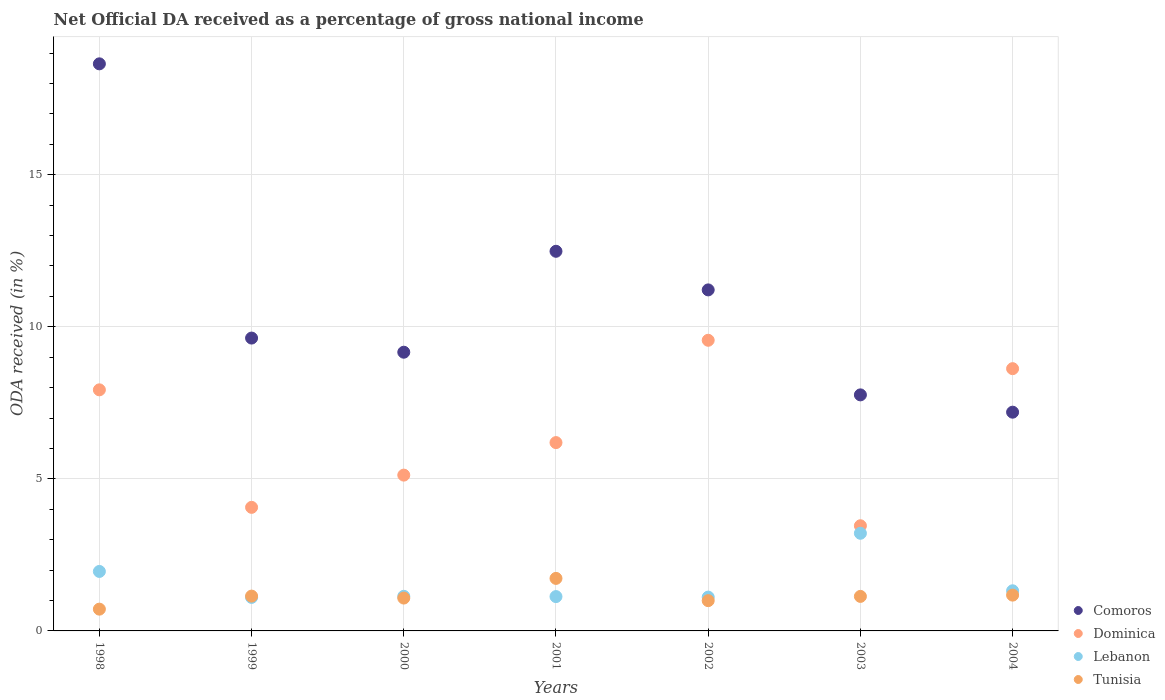Is the number of dotlines equal to the number of legend labels?
Offer a terse response. Yes. What is the net official DA received in Comoros in 2000?
Offer a terse response. 9.16. Across all years, what is the maximum net official DA received in Dominica?
Provide a succinct answer. 9.56. Across all years, what is the minimum net official DA received in Lebanon?
Ensure brevity in your answer.  1.1. In which year was the net official DA received in Dominica minimum?
Provide a short and direct response. 2003. What is the total net official DA received in Tunisia in the graph?
Keep it short and to the point. 7.98. What is the difference between the net official DA received in Comoros in 1999 and that in 2001?
Keep it short and to the point. -2.85. What is the difference between the net official DA received in Comoros in 2002 and the net official DA received in Dominica in 2000?
Offer a terse response. 6.09. What is the average net official DA received in Lebanon per year?
Make the answer very short. 1.57. In the year 1998, what is the difference between the net official DA received in Tunisia and net official DA received in Comoros?
Your response must be concise. -17.93. What is the ratio of the net official DA received in Dominica in 1998 to that in 2004?
Your answer should be very brief. 0.92. Is the net official DA received in Lebanon in 1998 less than that in 1999?
Make the answer very short. No. Is the difference between the net official DA received in Tunisia in 2000 and 2001 greater than the difference between the net official DA received in Comoros in 2000 and 2001?
Your response must be concise. Yes. What is the difference between the highest and the second highest net official DA received in Tunisia?
Your answer should be very brief. 0.55. What is the difference between the highest and the lowest net official DA received in Dominica?
Give a very brief answer. 6.1. Is the sum of the net official DA received in Lebanon in 1998 and 2004 greater than the maximum net official DA received in Dominica across all years?
Your answer should be compact. No. Is it the case that in every year, the sum of the net official DA received in Comoros and net official DA received in Tunisia  is greater than the sum of net official DA received in Lebanon and net official DA received in Dominica?
Provide a succinct answer. No. Is it the case that in every year, the sum of the net official DA received in Tunisia and net official DA received in Comoros  is greater than the net official DA received in Lebanon?
Keep it short and to the point. Yes. Is the net official DA received in Dominica strictly greater than the net official DA received in Lebanon over the years?
Make the answer very short. Yes. How many years are there in the graph?
Give a very brief answer. 7. What is the difference between two consecutive major ticks on the Y-axis?
Offer a very short reply. 5. Where does the legend appear in the graph?
Keep it short and to the point. Bottom right. How many legend labels are there?
Give a very brief answer. 4. How are the legend labels stacked?
Provide a succinct answer. Vertical. What is the title of the graph?
Your response must be concise. Net Official DA received as a percentage of gross national income. What is the label or title of the X-axis?
Make the answer very short. Years. What is the label or title of the Y-axis?
Your answer should be compact. ODA received (in %). What is the ODA received (in %) in Comoros in 1998?
Offer a terse response. 18.64. What is the ODA received (in %) of Dominica in 1998?
Provide a succinct answer. 7.93. What is the ODA received (in %) of Lebanon in 1998?
Your answer should be very brief. 1.96. What is the ODA received (in %) of Tunisia in 1998?
Make the answer very short. 0.72. What is the ODA received (in %) of Comoros in 1999?
Make the answer very short. 9.63. What is the ODA received (in %) of Dominica in 1999?
Offer a very short reply. 4.06. What is the ODA received (in %) in Lebanon in 1999?
Ensure brevity in your answer.  1.1. What is the ODA received (in %) in Tunisia in 1999?
Your response must be concise. 1.14. What is the ODA received (in %) in Comoros in 2000?
Offer a terse response. 9.16. What is the ODA received (in %) of Dominica in 2000?
Give a very brief answer. 5.12. What is the ODA received (in %) in Lebanon in 2000?
Provide a succinct answer. 1.14. What is the ODA received (in %) in Tunisia in 2000?
Your answer should be compact. 1.08. What is the ODA received (in %) of Comoros in 2001?
Give a very brief answer. 12.48. What is the ODA received (in %) in Dominica in 2001?
Your answer should be compact. 6.19. What is the ODA received (in %) in Lebanon in 2001?
Keep it short and to the point. 1.13. What is the ODA received (in %) of Tunisia in 2001?
Your answer should be compact. 1.73. What is the ODA received (in %) in Comoros in 2002?
Give a very brief answer. 11.21. What is the ODA received (in %) in Dominica in 2002?
Your answer should be compact. 9.56. What is the ODA received (in %) of Lebanon in 2002?
Make the answer very short. 1.11. What is the ODA received (in %) of Tunisia in 2002?
Your answer should be very brief. 1. What is the ODA received (in %) of Comoros in 2003?
Your answer should be very brief. 7.76. What is the ODA received (in %) in Dominica in 2003?
Ensure brevity in your answer.  3.46. What is the ODA received (in %) of Lebanon in 2003?
Offer a very short reply. 3.21. What is the ODA received (in %) in Tunisia in 2003?
Your answer should be compact. 1.14. What is the ODA received (in %) of Comoros in 2004?
Your answer should be compact. 7.19. What is the ODA received (in %) of Dominica in 2004?
Your response must be concise. 8.62. What is the ODA received (in %) in Lebanon in 2004?
Your answer should be very brief. 1.32. What is the ODA received (in %) in Tunisia in 2004?
Your response must be concise. 1.18. Across all years, what is the maximum ODA received (in %) in Comoros?
Offer a terse response. 18.64. Across all years, what is the maximum ODA received (in %) in Dominica?
Offer a very short reply. 9.56. Across all years, what is the maximum ODA received (in %) of Lebanon?
Offer a terse response. 3.21. Across all years, what is the maximum ODA received (in %) of Tunisia?
Offer a very short reply. 1.73. Across all years, what is the minimum ODA received (in %) in Comoros?
Your response must be concise. 7.19. Across all years, what is the minimum ODA received (in %) in Dominica?
Make the answer very short. 3.46. Across all years, what is the minimum ODA received (in %) in Lebanon?
Give a very brief answer. 1.1. Across all years, what is the minimum ODA received (in %) in Tunisia?
Offer a terse response. 0.72. What is the total ODA received (in %) in Comoros in the graph?
Your response must be concise. 76.08. What is the total ODA received (in %) of Dominica in the graph?
Provide a short and direct response. 44.94. What is the total ODA received (in %) of Lebanon in the graph?
Ensure brevity in your answer.  10.97. What is the total ODA received (in %) of Tunisia in the graph?
Make the answer very short. 7.98. What is the difference between the ODA received (in %) in Comoros in 1998 and that in 1999?
Ensure brevity in your answer.  9.02. What is the difference between the ODA received (in %) of Dominica in 1998 and that in 1999?
Keep it short and to the point. 3.86. What is the difference between the ODA received (in %) in Lebanon in 1998 and that in 1999?
Ensure brevity in your answer.  0.85. What is the difference between the ODA received (in %) in Tunisia in 1998 and that in 1999?
Provide a short and direct response. -0.43. What is the difference between the ODA received (in %) of Comoros in 1998 and that in 2000?
Keep it short and to the point. 9.48. What is the difference between the ODA received (in %) of Dominica in 1998 and that in 2000?
Your response must be concise. 2.8. What is the difference between the ODA received (in %) of Lebanon in 1998 and that in 2000?
Your answer should be compact. 0.82. What is the difference between the ODA received (in %) in Tunisia in 1998 and that in 2000?
Your answer should be very brief. -0.36. What is the difference between the ODA received (in %) in Comoros in 1998 and that in 2001?
Your answer should be compact. 6.16. What is the difference between the ODA received (in %) of Dominica in 1998 and that in 2001?
Your answer should be very brief. 1.73. What is the difference between the ODA received (in %) of Lebanon in 1998 and that in 2001?
Your response must be concise. 0.83. What is the difference between the ODA received (in %) in Tunisia in 1998 and that in 2001?
Provide a succinct answer. -1.01. What is the difference between the ODA received (in %) of Comoros in 1998 and that in 2002?
Your response must be concise. 7.43. What is the difference between the ODA received (in %) in Dominica in 1998 and that in 2002?
Make the answer very short. -1.63. What is the difference between the ODA received (in %) of Lebanon in 1998 and that in 2002?
Give a very brief answer. 0.84. What is the difference between the ODA received (in %) in Tunisia in 1998 and that in 2002?
Make the answer very short. -0.28. What is the difference between the ODA received (in %) in Comoros in 1998 and that in 2003?
Provide a short and direct response. 10.88. What is the difference between the ODA received (in %) in Dominica in 1998 and that in 2003?
Provide a short and direct response. 4.47. What is the difference between the ODA received (in %) in Lebanon in 1998 and that in 2003?
Ensure brevity in your answer.  -1.25. What is the difference between the ODA received (in %) in Tunisia in 1998 and that in 2003?
Offer a very short reply. -0.42. What is the difference between the ODA received (in %) of Comoros in 1998 and that in 2004?
Keep it short and to the point. 11.45. What is the difference between the ODA received (in %) in Dominica in 1998 and that in 2004?
Provide a short and direct response. -0.7. What is the difference between the ODA received (in %) in Lebanon in 1998 and that in 2004?
Give a very brief answer. 0.64. What is the difference between the ODA received (in %) in Tunisia in 1998 and that in 2004?
Give a very brief answer. -0.46. What is the difference between the ODA received (in %) in Comoros in 1999 and that in 2000?
Give a very brief answer. 0.47. What is the difference between the ODA received (in %) of Dominica in 1999 and that in 2000?
Give a very brief answer. -1.06. What is the difference between the ODA received (in %) of Lebanon in 1999 and that in 2000?
Keep it short and to the point. -0.04. What is the difference between the ODA received (in %) of Tunisia in 1999 and that in 2000?
Provide a short and direct response. 0.06. What is the difference between the ODA received (in %) in Comoros in 1999 and that in 2001?
Ensure brevity in your answer.  -2.85. What is the difference between the ODA received (in %) of Dominica in 1999 and that in 2001?
Keep it short and to the point. -2.13. What is the difference between the ODA received (in %) in Lebanon in 1999 and that in 2001?
Keep it short and to the point. -0.03. What is the difference between the ODA received (in %) of Tunisia in 1999 and that in 2001?
Provide a short and direct response. -0.58. What is the difference between the ODA received (in %) of Comoros in 1999 and that in 2002?
Your response must be concise. -1.58. What is the difference between the ODA received (in %) of Dominica in 1999 and that in 2002?
Keep it short and to the point. -5.49. What is the difference between the ODA received (in %) in Lebanon in 1999 and that in 2002?
Give a very brief answer. -0.01. What is the difference between the ODA received (in %) of Tunisia in 1999 and that in 2002?
Provide a succinct answer. 0.15. What is the difference between the ODA received (in %) of Comoros in 1999 and that in 2003?
Make the answer very short. 1.87. What is the difference between the ODA received (in %) of Dominica in 1999 and that in 2003?
Offer a terse response. 0.61. What is the difference between the ODA received (in %) in Lebanon in 1999 and that in 2003?
Offer a terse response. -2.11. What is the difference between the ODA received (in %) in Tunisia in 1999 and that in 2003?
Offer a terse response. 0.01. What is the difference between the ODA received (in %) in Comoros in 1999 and that in 2004?
Provide a short and direct response. 2.44. What is the difference between the ODA received (in %) in Dominica in 1999 and that in 2004?
Make the answer very short. -4.56. What is the difference between the ODA received (in %) of Lebanon in 1999 and that in 2004?
Offer a very short reply. -0.22. What is the difference between the ODA received (in %) of Tunisia in 1999 and that in 2004?
Give a very brief answer. -0.03. What is the difference between the ODA received (in %) of Comoros in 2000 and that in 2001?
Give a very brief answer. -3.32. What is the difference between the ODA received (in %) in Dominica in 2000 and that in 2001?
Give a very brief answer. -1.07. What is the difference between the ODA received (in %) in Lebanon in 2000 and that in 2001?
Provide a short and direct response. 0.01. What is the difference between the ODA received (in %) in Tunisia in 2000 and that in 2001?
Give a very brief answer. -0.65. What is the difference between the ODA received (in %) in Comoros in 2000 and that in 2002?
Provide a succinct answer. -2.05. What is the difference between the ODA received (in %) in Dominica in 2000 and that in 2002?
Keep it short and to the point. -4.43. What is the difference between the ODA received (in %) in Lebanon in 2000 and that in 2002?
Give a very brief answer. 0.03. What is the difference between the ODA received (in %) of Tunisia in 2000 and that in 2002?
Ensure brevity in your answer.  0.09. What is the difference between the ODA received (in %) in Comoros in 2000 and that in 2003?
Keep it short and to the point. 1.4. What is the difference between the ODA received (in %) of Dominica in 2000 and that in 2003?
Make the answer very short. 1.67. What is the difference between the ODA received (in %) in Lebanon in 2000 and that in 2003?
Ensure brevity in your answer.  -2.07. What is the difference between the ODA received (in %) of Tunisia in 2000 and that in 2003?
Offer a very short reply. -0.05. What is the difference between the ODA received (in %) in Comoros in 2000 and that in 2004?
Your answer should be compact. 1.97. What is the difference between the ODA received (in %) in Dominica in 2000 and that in 2004?
Provide a succinct answer. -3.5. What is the difference between the ODA received (in %) in Lebanon in 2000 and that in 2004?
Your response must be concise. -0.18. What is the difference between the ODA received (in %) in Tunisia in 2000 and that in 2004?
Provide a short and direct response. -0.1. What is the difference between the ODA received (in %) in Comoros in 2001 and that in 2002?
Keep it short and to the point. 1.27. What is the difference between the ODA received (in %) of Dominica in 2001 and that in 2002?
Offer a terse response. -3.36. What is the difference between the ODA received (in %) in Lebanon in 2001 and that in 2002?
Offer a very short reply. 0.02. What is the difference between the ODA received (in %) of Tunisia in 2001 and that in 2002?
Make the answer very short. 0.73. What is the difference between the ODA received (in %) in Comoros in 2001 and that in 2003?
Offer a terse response. 4.72. What is the difference between the ODA received (in %) of Dominica in 2001 and that in 2003?
Provide a succinct answer. 2.73. What is the difference between the ODA received (in %) in Lebanon in 2001 and that in 2003?
Keep it short and to the point. -2.08. What is the difference between the ODA received (in %) of Tunisia in 2001 and that in 2003?
Your answer should be very brief. 0.59. What is the difference between the ODA received (in %) in Comoros in 2001 and that in 2004?
Offer a terse response. 5.29. What is the difference between the ODA received (in %) in Dominica in 2001 and that in 2004?
Give a very brief answer. -2.43. What is the difference between the ODA received (in %) of Lebanon in 2001 and that in 2004?
Provide a succinct answer. -0.19. What is the difference between the ODA received (in %) in Tunisia in 2001 and that in 2004?
Make the answer very short. 0.55. What is the difference between the ODA received (in %) in Comoros in 2002 and that in 2003?
Your answer should be compact. 3.45. What is the difference between the ODA received (in %) in Dominica in 2002 and that in 2003?
Give a very brief answer. 6.1. What is the difference between the ODA received (in %) of Lebanon in 2002 and that in 2003?
Offer a terse response. -2.1. What is the difference between the ODA received (in %) of Tunisia in 2002 and that in 2003?
Your response must be concise. -0.14. What is the difference between the ODA received (in %) in Comoros in 2002 and that in 2004?
Make the answer very short. 4.02. What is the difference between the ODA received (in %) of Dominica in 2002 and that in 2004?
Provide a short and direct response. 0.93. What is the difference between the ODA received (in %) of Lebanon in 2002 and that in 2004?
Make the answer very short. -0.21. What is the difference between the ODA received (in %) in Tunisia in 2002 and that in 2004?
Give a very brief answer. -0.18. What is the difference between the ODA received (in %) in Comoros in 2003 and that in 2004?
Ensure brevity in your answer.  0.57. What is the difference between the ODA received (in %) in Dominica in 2003 and that in 2004?
Your answer should be very brief. -5.16. What is the difference between the ODA received (in %) in Lebanon in 2003 and that in 2004?
Offer a terse response. 1.89. What is the difference between the ODA received (in %) in Tunisia in 2003 and that in 2004?
Keep it short and to the point. -0.04. What is the difference between the ODA received (in %) in Comoros in 1998 and the ODA received (in %) in Dominica in 1999?
Keep it short and to the point. 14.58. What is the difference between the ODA received (in %) in Comoros in 1998 and the ODA received (in %) in Lebanon in 1999?
Offer a terse response. 17.54. What is the difference between the ODA received (in %) in Comoros in 1998 and the ODA received (in %) in Tunisia in 1999?
Ensure brevity in your answer.  17.5. What is the difference between the ODA received (in %) of Dominica in 1998 and the ODA received (in %) of Lebanon in 1999?
Give a very brief answer. 6.82. What is the difference between the ODA received (in %) of Dominica in 1998 and the ODA received (in %) of Tunisia in 1999?
Offer a terse response. 6.78. What is the difference between the ODA received (in %) in Lebanon in 1998 and the ODA received (in %) in Tunisia in 1999?
Offer a terse response. 0.81. What is the difference between the ODA received (in %) of Comoros in 1998 and the ODA received (in %) of Dominica in 2000?
Make the answer very short. 13.52. What is the difference between the ODA received (in %) in Comoros in 1998 and the ODA received (in %) in Lebanon in 2000?
Your response must be concise. 17.51. What is the difference between the ODA received (in %) of Comoros in 1998 and the ODA received (in %) of Tunisia in 2000?
Ensure brevity in your answer.  17.56. What is the difference between the ODA received (in %) in Dominica in 1998 and the ODA received (in %) in Lebanon in 2000?
Ensure brevity in your answer.  6.79. What is the difference between the ODA received (in %) of Dominica in 1998 and the ODA received (in %) of Tunisia in 2000?
Offer a terse response. 6.85. What is the difference between the ODA received (in %) of Lebanon in 1998 and the ODA received (in %) of Tunisia in 2000?
Make the answer very short. 0.88. What is the difference between the ODA received (in %) of Comoros in 1998 and the ODA received (in %) of Dominica in 2001?
Ensure brevity in your answer.  12.45. What is the difference between the ODA received (in %) of Comoros in 1998 and the ODA received (in %) of Lebanon in 2001?
Make the answer very short. 17.52. What is the difference between the ODA received (in %) of Comoros in 1998 and the ODA received (in %) of Tunisia in 2001?
Your answer should be compact. 16.92. What is the difference between the ODA received (in %) of Dominica in 1998 and the ODA received (in %) of Lebanon in 2001?
Give a very brief answer. 6.8. What is the difference between the ODA received (in %) in Dominica in 1998 and the ODA received (in %) in Tunisia in 2001?
Give a very brief answer. 6.2. What is the difference between the ODA received (in %) in Lebanon in 1998 and the ODA received (in %) in Tunisia in 2001?
Give a very brief answer. 0.23. What is the difference between the ODA received (in %) in Comoros in 1998 and the ODA received (in %) in Dominica in 2002?
Your response must be concise. 9.09. What is the difference between the ODA received (in %) in Comoros in 1998 and the ODA received (in %) in Lebanon in 2002?
Your answer should be compact. 17.53. What is the difference between the ODA received (in %) of Comoros in 1998 and the ODA received (in %) of Tunisia in 2002?
Offer a very short reply. 17.65. What is the difference between the ODA received (in %) of Dominica in 1998 and the ODA received (in %) of Lebanon in 2002?
Offer a terse response. 6.81. What is the difference between the ODA received (in %) of Dominica in 1998 and the ODA received (in %) of Tunisia in 2002?
Offer a very short reply. 6.93. What is the difference between the ODA received (in %) in Lebanon in 1998 and the ODA received (in %) in Tunisia in 2002?
Provide a succinct answer. 0.96. What is the difference between the ODA received (in %) in Comoros in 1998 and the ODA received (in %) in Dominica in 2003?
Provide a succinct answer. 15.19. What is the difference between the ODA received (in %) of Comoros in 1998 and the ODA received (in %) of Lebanon in 2003?
Provide a short and direct response. 15.43. What is the difference between the ODA received (in %) in Comoros in 1998 and the ODA received (in %) in Tunisia in 2003?
Provide a short and direct response. 17.51. What is the difference between the ODA received (in %) in Dominica in 1998 and the ODA received (in %) in Lebanon in 2003?
Give a very brief answer. 4.72. What is the difference between the ODA received (in %) of Dominica in 1998 and the ODA received (in %) of Tunisia in 2003?
Provide a short and direct response. 6.79. What is the difference between the ODA received (in %) in Lebanon in 1998 and the ODA received (in %) in Tunisia in 2003?
Offer a terse response. 0.82. What is the difference between the ODA received (in %) in Comoros in 1998 and the ODA received (in %) in Dominica in 2004?
Offer a terse response. 10.02. What is the difference between the ODA received (in %) of Comoros in 1998 and the ODA received (in %) of Lebanon in 2004?
Your answer should be very brief. 17.32. What is the difference between the ODA received (in %) of Comoros in 1998 and the ODA received (in %) of Tunisia in 2004?
Offer a very short reply. 17.47. What is the difference between the ODA received (in %) in Dominica in 1998 and the ODA received (in %) in Lebanon in 2004?
Provide a succinct answer. 6.61. What is the difference between the ODA received (in %) in Dominica in 1998 and the ODA received (in %) in Tunisia in 2004?
Offer a terse response. 6.75. What is the difference between the ODA received (in %) in Lebanon in 1998 and the ODA received (in %) in Tunisia in 2004?
Keep it short and to the point. 0.78. What is the difference between the ODA received (in %) in Comoros in 1999 and the ODA received (in %) in Dominica in 2000?
Offer a very short reply. 4.51. What is the difference between the ODA received (in %) in Comoros in 1999 and the ODA received (in %) in Lebanon in 2000?
Offer a terse response. 8.49. What is the difference between the ODA received (in %) of Comoros in 1999 and the ODA received (in %) of Tunisia in 2000?
Give a very brief answer. 8.55. What is the difference between the ODA received (in %) in Dominica in 1999 and the ODA received (in %) in Lebanon in 2000?
Make the answer very short. 2.93. What is the difference between the ODA received (in %) of Dominica in 1999 and the ODA received (in %) of Tunisia in 2000?
Your response must be concise. 2.98. What is the difference between the ODA received (in %) in Lebanon in 1999 and the ODA received (in %) in Tunisia in 2000?
Provide a short and direct response. 0.02. What is the difference between the ODA received (in %) in Comoros in 1999 and the ODA received (in %) in Dominica in 2001?
Your response must be concise. 3.44. What is the difference between the ODA received (in %) of Comoros in 1999 and the ODA received (in %) of Lebanon in 2001?
Provide a short and direct response. 8.5. What is the difference between the ODA received (in %) in Comoros in 1999 and the ODA received (in %) in Tunisia in 2001?
Your answer should be compact. 7.9. What is the difference between the ODA received (in %) of Dominica in 1999 and the ODA received (in %) of Lebanon in 2001?
Your response must be concise. 2.93. What is the difference between the ODA received (in %) in Dominica in 1999 and the ODA received (in %) in Tunisia in 2001?
Offer a terse response. 2.34. What is the difference between the ODA received (in %) in Lebanon in 1999 and the ODA received (in %) in Tunisia in 2001?
Your answer should be compact. -0.62. What is the difference between the ODA received (in %) in Comoros in 1999 and the ODA received (in %) in Dominica in 2002?
Keep it short and to the point. 0.07. What is the difference between the ODA received (in %) of Comoros in 1999 and the ODA received (in %) of Lebanon in 2002?
Provide a succinct answer. 8.52. What is the difference between the ODA received (in %) in Comoros in 1999 and the ODA received (in %) in Tunisia in 2002?
Your response must be concise. 8.63. What is the difference between the ODA received (in %) in Dominica in 1999 and the ODA received (in %) in Lebanon in 2002?
Your response must be concise. 2.95. What is the difference between the ODA received (in %) in Dominica in 1999 and the ODA received (in %) in Tunisia in 2002?
Provide a short and direct response. 3.07. What is the difference between the ODA received (in %) of Lebanon in 1999 and the ODA received (in %) of Tunisia in 2002?
Your answer should be very brief. 0.11. What is the difference between the ODA received (in %) of Comoros in 1999 and the ODA received (in %) of Dominica in 2003?
Your answer should be compact. 6.17. What is the difference between the ODA received (in %) in Comoros in 1999 and the ODA received (in %) in Lebanon in 2003?
Your response must be concise. 6.42. What is the difference between the ODA received (in %) of Comoros in 1999 and the ODA received (in %) of Tunisia in 2003?
Provide a succinct answer. 8.49. What is the difference between the ODA received (in %) in Dominica in 1999 and the ODA received (in %) in Lebanon in 2003?
Provide a succinct answer. 0.85. What is the difference between the ODA received (in %) in Dominica in 1999 and the ODA received (in %) in Tunisia in 2003?
Provide a short and direct response. 2.93. What is the difference between the ODA received (in %) in Lebanon in 1999 and the ODA received (in %) in Tunisia in 2003?
Make the answer very short. -0.03. What is the difference between the ODA received (in %) in Comoros in 1999 and the ODA received (in %) in Dominica in 2004?
Provide a succinct answer. 1.01. What is the difference between the ODA received (in %) in Comoros in 1999 and the ODA received (in %) in Lebanon in 2004?
Provide a succinct answer. 8.31. What is the difference between the ODA received (in %) in Comoros in 1999 and the ODA received (in %) in Tunisia in 2004?
Ensure brevity in your answer.  8.45. What is the difference between the ODA received (in %) in Dominica in 1999 and the ODA received (in %) in Lebanon in 2004?
Give a very brief answer. 2.74. What is the difference between the ODA received (in %) of Dominica in 1999 and the ODA received (in %) of Tunisia in 2004?
Your answer should be compact. 2.89. What is the difference between the ODA received (in %) in Lebanon in 1999 and the ODA received (in %) in Tunisia in 2004?
Give a very brief answer. -0.07. What is the difference between the ODA received (in %) in Comoros in 2000 and the ODA received (in %) in Dominica in 2001?
Make the answer very short. 2.97. What is the difference between the ODA received (in %) of Comoros in 2000 and the ODA received (in %) of Lebanon in 2001?
Ensure brevity in your answer.  8.03. What is the difference between the ODA received (in %) in Comoros in 2000 and the ODA received (in %) in Tunisia in 2001?
Offer a very short reply. 7.44. What is the difference between the ODA received (in %) in Dominica in 2000 and the ODA received (in %) in Lebanon in 2001?
Keep it short and to the point. 3.99. What is the difference between the ODA received (in %) in Dominica in 2000 and the ODA received (in %) in Tunisia in 2001?
Your answer should be very brief. 3.4. What is the difference between the ODA received (in %) of Lebanon in 2000 and the ODA received (in %) of Tunisia in 2001?
Give a very brief answer. -0.59. What is the difference between the ODA received (in %) in Comoros in 2000 and the ODA received (in %) in Dominica in 2002?
Give a very brief answer. -0.39. What is the difference between the ODA received (in %) in Comoros in 2000 and the ODA received (in %) in Lebanon in 2002?
Make the answer very short. 8.05. What is the difference between the ODA received (in %) of Comoros in 2000 and the ODA received (in %) of Tunisia in 2002?
Your response must be concise. 8.17. What is the difference between the ODA received (in %) of Dominica in 2000 and the ODA received (in %) of Lebanon in 2002?
Keep it short and to the point. 4.01. What is the difference between the ODA received (in %) in Dominica in 2000 and the ODA received (in %) in Tunisia in 2002?
Offer a very short reply. 4.13. What is the difference between the ODA received (in %) of Lebanon in 2000 and the ODA received (in %) of Tunisia in 2002?
Ensure brevity in your answer.  0.14. What is the difference between the ODA received (in %) in Comoros in 2000 and the ODA received (in %) in Dominica in 2003?
Your answer should be compact. 5.71. What is the difference between the ODA received (in %) in Comoros in 2000 and the ODA received (in %) in Lebanon in 2003?
Offer a very short reply. 5.95. What is the difference between the ODA received (in %) of Comoros in 2000 and the ODA received (in %) of Tunisia in 2003?
Provide a succinct answer. 8.03. What is the difference between the ODA received (in %) of Dominica in 2000 and the ODA received (in %) of Lebanon in 2003?
Offer a very short reply. 1.91. What is the difference between the ODA received (in %) of Dominica in 2000 and the ODA received (in %) of Tunisia in 2003?
Your answer should be very brief. 3.99. What is the difference between the ODA received (in %) of Lebanon in 2000 and the ODA received (in %) of Tunisia in 2003?
Provide a succinct answer. 0. What is the difference between the ODA received (in %) of Comoros in 2000 and the ODA received (in %) of Dominica in 2004?
Provide a short and direct response. 0.54. What is the difference between the ODA received (in %) of Comoros in 2000 and the ODA received (in %) of Lebanon in 2004?
Provide a short and direct response. 7.84. What is the difference between the ODA received (in %) of Comoros in 2000 and the ODA received (in %) of Tunisia in 2004?
Your response must be concise. 7.99. What is the difference between the ODA received (in %) in Dominica in 2000 and the ODA received (in %) in Lebanon in 2004?
Make the answer very short. 3.8. What is the difference between the ODA received (in %) in Dominica in 2000 and the ODA received (in %) in Tunisia in 2004?
Your answer should be compact. 3.95. What is the difference between the ODA received (in %) in Lebanon in 2000 and the ODA received (in %) in Tunisia in 2004?
Provide a succinct answer. -0.04. What is the difference between the ODA received (in %) of Comoros in 2001 and the ODA received (in %) of Dominica in 2002?
Provide a short and direct response. 2.93. What is the difference between the ODA received (in %) in Comoros in 2001 and the ODA received (in %) in Lebanon in 2002?
Your answer should be very brief. 11.37. What is the difference between the ODA received (in %) in Comoros in 2001 and the ODA received (in %) in Tunisia in 2002?
Your answer should be compact. 11.49. What is the difference between the ODA received (in %) in Dominica in 2001 and the ODA received (in %) in Lebanon in 2002?
Give a very brief answer. 5.08. What is the difference between the ODA received (in %) in Dominica in 2001 and the ODA received (in %) in Tunisia in 2002?
Provide a short and direct response. 5.2. What is the difference between the ODA received (in %) of Lebanon in 2001 and the ODA received (in %) of Tunisia in 2002?
Offer a terse response. 0.13. What is the difference between the ODA received (in %) in Comoros in 2001 and the ODA received (in %) in Dominica in 2003?
Your answer should be very brief. 9.02. What is the difference between the ODA received (in %) of Comoros in 2001 and the ODA received (in %) of Lebanon in 2003?
Your response must be concise. 9.27. What is the difference between the ODA received (in %) in Comoros in 2001 and the ODA received (in %) in Tunisia in 2003?
Offer a very short reply. 11.35. What is the difference between the ODA received (in %) in Dominica in 2001 and the ODA received (in %) in Lebanon in 2003?
Your answer should be compact. 2.98. What is the difference between the ODA received (in %) of Dominica in 2001 and the ODA received (in %) of Tunisia in 2003?
Keep it short and to the point. 5.06. What is the difference between the ODA received (in %) in Lebanon in 2001 and the ODA received (in %) in Tunisia in 2003?
Your answer should be very brief. -0.01. What is the difference between the ODA received (in %) in Comoros in 2001 and the ODA received (in %) in Dominica in 2004?
Offer a terse response. 3.86. What is the difference between the ODA received (in %) of Comoros in 2001 and the ODA received (in %) of Lebanon in 2004?
Make the answer very short. 11.16. What is the difference between the ODA received (in %) of Comoros in 2001 and the ODA received (in %) of Tunisia in 2004?
Your answer should be compact. 11.3. What is the difference between the ODA received (in %) in Dominica in 2001 and the ODA received (in %) in Lebanon in 2004?
Provide a succinct answer. 4.87. What is the difference between the ODA received (in %) of Dominica in 2001 and the ODA received (in %) of Tunisia in 2004?
Your answer should be very brief. 5.01. What is the difference between the ODA received (in %) of Lebanon in 2001 and the ODA received (in %) of Tunisia in 2004?
Offer a very short reply. -0.05. What is the difference between the ODA received (in %) of Comoros in 2002 and the ODA received (in %) of Dominica in 2003?
Offer a terse response. 7.75. What is the difference between the ODA received (in %) of Comoros in 2002 and the ODA received (in %) of Lebanon in 2003?
Your answer should be very brief. 8. What is the difference between the ODA received (in %) of Comoros in 2002 and the ODA received (in %) of Tunisia in 2003?
Keep it short and to the point. 10.08. What is the difference between the ODA received (in %) of Dominica in 2002 and the ODA received (in %) of Lebanon in 2003?
Offer a terse response. 6.35. What is the difference between the ODA received (in %) of Dominica in 2002 and the ODA received (in %) of Tunisia in 2003?
Provide a succinct answer. 8.42. What is the difference between the ODA received (in %) of Lebanon in 2002 and the ODA received (in %) of Tunisia in 2003?
Ensure brevity in your answer.  -0.02. What is the difference between the ODA received (in %) in Comoros in 2002 and the ODA received (in %) in Dominica in 2004?
Keep it short and to the point. 2.59. What is the difference between the ODA received (in %) of Comoros in 2002 and the ODA received (in %) of Lebanon in 2004?
Your answer should be very brief. 9.89. What is the difference between the ODA received (in %) of Comoros in 2002 and the ODA received (in %) of Tunisia in 2004?
Offer a very short reply. 10.04. What is the difference between the ODA received (in %) in Dominica in 2002 and the ODA received (in %) in Lebanon in 2004?
Provide a short and direct response. 8.24. What is the difference between the ODA received (in %) in Dominica in 2002 and the ODA received (in %) in Tunisia in 2004?
Your answer should be compact. 8.38. What is the difference between the ODA received (in %) in Lebanon in 2002 and the ODA received (in %) in Tunisia in 2004?
Ensure brevity in your answer.  -0.07. What is the difference between the ODA received (in %) of Comoros in 2003 and the ODA received (in %) of Dominica in 2004?
Your answer should be very brief. -0.86. What is the difference between the ODA received (in %) in Comoros in 2003 and the ODA received (in %) in Lebanon in 2004?
Keep it short and to the point. 6.44. What is the difference between the ODA received (in %) in Comoros in 2003 and the ODA received (in %) in Tunisia in 2004?
Provide a short and direct response. 6.58. What is the difference between the ODA received (in %) in Dominica in 2003 and the ODA received (in %) in Lebanon in 2004?
Offer a terse response. 2.14. What is the difference between the ODA received (in %) of Dominica in 2003 and the ODA received (in %) of Tunisia in 2004?
Provide a succinct answer. 2.28. What is the difference between the ODA received (in %) of Lebanon in 2003 and the ODA received (in %) of Tunisia in 2004?
Make the answer very short. 2.03. What is the average ODA received (in %) in Comoros per year?
Give a very brief answer. 10.87. What is the average ODA received (in %) in Dominica per year?
Provide a succinct answer. 6.42. What is the average ODA received (in %) in Lebanon per year?
Provide a short and direct response. 1.57. What is the average ODA received (in %) of Tunisia per year?
Keep it short and to the point. 1.14. In the year 1998, what is the difference between the ODA received (in %) in Comoros and ODA received (in %) in Dominica?
Offer a very short reply. 10.72. In the year 1998, what is the difference between the ODA received (in %) of Comoros and ODA received (in %) of Lebanon?
Provide a short and direct response. 16.69. In the year 1998, what is the difference between the ODA received (in %) in Comoros and ODA received (in %) in Tunisia?
Give a very brief answer. 17.93. In the year 1998, what is the difference between the ODA received (in %) in Dominica and ODA received (in %) in Lebanon?
Your response must be concise. 5.97. In the year 1998, what is the difference between the ODA received (in %) in Dominica and ODA received (in %) in Tunisia?
Provide a succinct answer. 7.21. In the year 1998, what is the difference between the ODA received (in %) in Lebanon and ODA received (in %) in Tunisia?
Your response must be concise. 1.24. In the year 1999, what is the difference between the ODA received (in %) of Comoros and ODA received (in %) of Dominica?
Keep it short and to the point. 5.57. In the year 1999, what is the difference between the ODA received (in %) of Comoros and ODA received (in %) of Lebanon?
Give a very brief answer. 8.53. In the year 1999, what is the difference between the ODA received (in %) in Comoros and ODA received (in %) in Tunisia?
Offer a terse response. 8.48. In the year 1999, what is the difference between the ODA received (in %) in Dominica and ODA received (in %) in Lebanon?
Your answer should be very brief. 2.96. In the year 1999, what is the difference between the ODA received (in %) in Dominica and ODA received (in %) in Tunisia?
Keep it short and to the point. 2.92. In the year 1999, what is the difference between the ODA received (in %) in Lebanon and ODA received (in %) in Tunisia?
Provide a short and direct response. -0.04. In the year 2000, what is the difference between the ODA received (in %) of Comoros and ODA received (in %) of Dominica?
Your answer should be very brief. 4.04. In the year 2000, what is the difference between the ODA received (in %) of Comoros and ODA received (in %) of Lebanon?
Give a very brief answer. 8.03. In the year 2000, what is the difference between the ODA received (in %) of Comoros and ODA received (in %) of Tunisia?
Ensure brevity in your answer.  8.08. In the year 2000, what is the difference between the ODA received (in %) of Dominica and ODA received (in %) of Lebanon?
Your answer should be compact. 3.98. In the year 2000, what is the difference between the ODA received (in %) of Dominica and ODA received (in %) of Tunisia?
Your answer should be very brief. 4.04. In the year 2000, what is the difference between the ODA received (in %) of Lebanon and ODA received (in %) of Tunisia?
Your response must be concise. 0.06. In the year 2001, what is the difference between the ODA received (in %) in Comoros and ODA received (in %) in Dominica?
Your response must be concise. 6.29. In the year 2001, what is the difference between the ODA received (in %) of Comoros and ODA received (in %) of Lebanon?
Make the answer very short. 11.35. In the year 2001, what is the difference between the ODA received (in %) of Comoros and ODA received (in %) of Tunisia?
Offer a terse response. 10.75. In the year 2001, what is the difference between the ODA received (in %) of Dominica and ODA received (in %) of Lebanon?
Offer a very short reply. 5.06. In the year 2001, what is the difference between the ODA received (in %) of Dominica and ODA received (in %) of Tunisia?
Your answer should be compact. 4.46. In the year 2001, what is the difference between the ODA received (in %) of Lebanon and ODA received (in %) of Tunisia?
Offer a terse response. -0.6. In the year 2002, what is the difference between the ODA received (in %) of Comoros and ODA received (in %) of Dominica?
Offer a terse response. 1.66. In the year 2002, what is the difference between the ODA received (in %) of Comoros and ODA received (in %) of Lebanon?
Offer a very short reply. 10.1. In the year 2002, what is the difference between the ODA received (in %) in Comoros and ODA received (in %) in Tunisia?
Provide a succinct answer. 10.22. In the year 2002, what is the difference between the ODA received (in %) of Dominica and ODA received (in %) of Lebanon?
Keep it short and to the point. 8.44. In the year 2002, what is the difference between the ODA received (in %) of Dominica and ODA received (in %) of Tunisia?
Provide a short and direct response. 8.56. In the year 2002, what is the difference between the ODA received (in %) of Lebanon and ODA received (in %) of Tunisia?
Give a very brief answer. 0.12. In the year 2003, what is the difference between the ODA received (in %) of Comoros and ODA received (in %) of Dominica?
Your response must be concise. 4.3. In the year 2003, what is the difference between the ODA received (in %) of Comoros and ODA received (in %) of Lebanon?
Give a very brief answer. 4.55. In the year 2003, what is the difference between the ODA received (in %) in Comoros and ODA received (in %) in Tunisia?
Your answer should be compact. 6.63. In the year 2003, what is the difference between the ODA received (in %) of Dominica and ODA received (in %) of Lebanon?
Give a very brief answer. 0.25. In the year 2003, what is the difference between the ODA received (in %) in Dominica and ODA received (in %) in Tunisia?
Offer a very short reply. 2.32. In the year 2003, what is the difference between the ODA received (in %) in Lebanon and ODA received (in %) in Tunisia?
Offer a terse response. 2.08. In the year 2004, what is the difference between the ODA received (in %) of Comoros and ODA received (in %) of Dominica?
Your answer should be very brief. -1.43. In the year 2004, what is the difference between the ODA received (in %) in Comoros and ODA received (in %) in Lebanon?
Ensure brevity in your answer.  5.87. In the year 2004, what is the difference between the ODA received (in %) in Comoros and ODA received (in %) in Tunisia?
Your answer should be very brief. 6.01. In the year 2004, what is the difference between the ODA received (in %) in Dominica and ODA received (in %) in Lebanon?
Give a very brief answer. 7.3. In the year 2004, what is the difference between the ODA received (in %) in Dominica and ODA received (in %) in Tunisia?
Your answer should be compact. 7.45. In the year 2004, what is the difference between the ODA received (in %) of Lebanon and ODA received (in %) of Tunisia?
Offer a very short reply. 0.14. What is the ratio of the ODA received (in %) of Comoros in 1998 to that in 1999?
Your answer should be compact. 1.94. What is the ratio of the ODA received (in %) in Dominica in 1998 to that in 1999?
Provide a succinct answer. 1.95. What is the ratio of the ODA received (in %) of Lebanon in 1998 to that in 1999?
Ensure brevity in your answer.  1.77. What is the ratio of the ODA received (in %) in Tunisia in 1998 to that in 1999?
Your answer should be very brief. 0.63. What is the ratio of the ODA received (in %) of Comoros in 1998 to that in 2000?
Give a very brief answer. 2.03. What is the ratio of the ODA received (in %) of Dominica in 1998 to that in 2000?
Your answer should be compact. 1.55. What is the ratio of the ODA received (in %) of Lebanon in 1998 to that in 2000?
Provide a succinct answer. 1.72. What is the ratio of the ODA received (in %) of Tunisia in 1998 to that in 2000?
Your response must be concise. 0.66. What is the ratio of the ODA received (in %) of Comoros in 1998 to that in 2001?
Provide a short and direct response. 1.49. What is the ratio of the ODA received (in %) in Dominica in 1998 to that in 2001?
Your answer should be compact. 1.28. What is the ratio of the ODA received (in %) in Lebanon in 1998 to that in 2001?
Your answer should be very brief. 1.73. What is the ratio of the ODA received (in %) of Tunisia in 1998 to that in 2001?
Offer a terse response. 0.41. What is the ratio of the ODA received (in %) of Comoros in 1998 to that in 2002?
Your response must be concise. 1.66. What is the ratio of the ODA received (in %) in Dominica in 1998 to that in 2002?
Your answer should be compact. 0.83. What is the ratio of the ODA received (in %) in Lebanon in 1998 to that in 2002?
Offer a terse response. 1.76. What is the ratio of the ODA received (in %) of Tunisia in 1998 to that in 2002?
Your answer should be compact. 0.72. What is the ratio of the ODA received (in %) of Comoros in 1998 to that in 2003?
Keep it short and to the point. 2.4. What is the ratio of the ODA received (in %) in Dominica in 1998 to that in 2003?
Provide a succinct answer. 2.29. What is the ratio of the ODA received (in %) in Lebanon in 1998 to that in 2003?
Ensure brevity in your answer.  0.61. What is the ratio of the ODA received (in %) of Tunisia in 1998 to that in 2003?
Provide a short and direct response. 0.63. What is the ratio of the ODA received (in %) of Comoros in 1998 to that in 2004?
Your answer should be compact. 2.59. What is the ratio of the ODA received (in %) in Dominica in 1998 to that in 2004?
Keep it short and to the point. 0.92. What is the ratio of the ODA received (in %) of Lebanon in 1998 to that in 2004?
Your response must be concise. 1.48. What is the ratio of the ODA received (in %) of Tunisia in 1998 to that in 2004?
Provide a short and direct response. 0.61. What is the ratio of the ODA received (in %) in Comoros in 1999 to that in 2000?
Ensure brevity in your answer.  1.05. What is the ratio of the ODA received (in %) in Dominica in 1999 to that in 2000?
Keep it short and to the point. 0.79. What is the ratio of the ODA received (in %) of Lebanon in 1999 to that in 2000?
Your answer should be very brief. 0.97. What is the ratio of the ODA received (in %) in Tunisia in 1999 to that in 2000?
Keep it short and to the point. 1.06. What is the ratio of the ODA received (in %) of Comoros in 1999 to that in 2001?
Your response must be concise. 0.77. What is the ratio of the ODA received (in %) of Dominica in 1999 to that in 2001?
Give a very brief answer. 0.66. What is the ratio of the ODA received (in %) in Lebanon in 1999 to that in 2001?
Offer a terse response. 0.98. What is the ratio of the ODA received (in %) of Tunisia in 1999 to that in 2001?
Offer a very short reply. 0.66. What is the ratio of the ODA received (in %) in Comoros in 1999 to that in 2002?
Ensure brevity in your answer.  0.86. What is the ratio of the ODA received (in %) of Dominica in 1999 to that in 2002?
Provide a succinct answer. 0.43. What is the ratio of the ODA received (in %) in Lebanon in 1999 to that in 2002?
Your response must be concise. 0.99. What is the ratio of the ODA received (in %) in Tunisia in 1999 to that in 2002?
Offer a terse response. 1.15. What is the ratio of the ODA received (in %) of Comoros in 1999 to that in 2003?
Make the answer very short. 1.24. What is the ratio of the ODA received (in %) of Dominica in 1999 to that in 2003?
Keep it short and to the point. 1.18. What is the ratio of the ODA received (in %) in Lebanon in 1999 to that in 2003?
Give a very brief answer. 0.34. What is the ratio of the ODA received (in %) in Tunisia in 1999 to that in 2003?
Your response must be concise. 1.01. What is the ratio of the ODA received (in %) of Comoros in 1999 to that in 2004?
Provide a short and direct response. 1.34. What is the ratio of the ODA received (in %) of Dominica in 1999 to that in 2004?
Offer a very short reply. 0.47. What is the ratio of the ODA received (in %) of Lebanon in 1999 to that in 2004?
Offer a very short reply. 0.84. What is the ratio of the ODA received (in %) of Tunisia in 1999 to that in 2004?
Your response must be concise. 0.97. What is the ratio of the ODA received (in %) of Comoros in 2000 to that in 2001?
Provide a short and direct response. 0.73. What is the ratio of the ODA received (in %) in Dominica in 2000 to that in 2001?
Keep it short and to the point. 0.83. What is the ratio of the ODA received (in %) of Lebanon in 2000 to that in 2001?
Provide a succinct answer. 1.01. What is the ratio of the ODA received (in %) in Tunisia in 2000 to that in 2001?
Your response must be concise. 0.63. What is the ratio of the ODA received (in %) in Comoros in 2000 to that in 2002?
Your answer should be very brief. 0.82. What is the ratio of the ODA received (in %) of Dominica in 2000 to that in 2002?
Provide a succinct answer. 0.54. What is the ratio of the ODA received (in %) in Lebanon in 2000 to that in 2002?
Ensure brevity in your answer.  1.02. What is the ratio of the ODA received (in %) in Tunisia in 2000 to that in 2002?
Your answer should be very brief. 1.09. What is the ratio of the ODA received (in %) of Comoros in 2000 to that in 2003?
Provide a short and direct response. 1.18. What is the ratio of the ODA received (in %) in Dominica in 2000 to that in 2003?
Your answer should be very brief. 1.48. What is the ratio of the ODA received (in %) of Lebanon in 2000 to that in 2003?
Ensure brevity in your answer.  0.35. What is the ratio of the ODA received (in %) in Tunisia in 2000 to that in 2003?
Your answer should be compact. 0.95. What is the ratio of the ODA received (in %) in Comoros in 2000 to that in 2004?
Keep it short and to the point. 1.27. What is the ratio of the ODA received (in %) in Dominica in 2000 to that in 2004?
Your answer should be very brief. 0.59. What is the ratio of the ODA received (in %) in Lebanon in 2000 to that in 2004?
Your response must be concise. 0.86. What is the ratio of the ODA received (in %) in Tunisia in 2000 to that in 2004?
Offer a very short reply. 0.92. What is the ratio of the ODA received (in %) in Comoros in 2001 to that in 2002?
Make the answer very short. 1.11. What is the ratio of the ODA received (in %) of Dominica in 2001 to that in 2002?
Provide a succinct answer. 0.65. What is the ratio of the ODA received (in %) of Lebanon in 2001 to that in 2002?
Keep it short and to the point. 1.02. What is the ratio of the ODA received (in %) in Tunisia in 2001 to that in 2002?
Keep it short and to the point. 1.74. What is the ratio of the ODA received (in %) of Comoros in 2001 to that in 2003?
Give a very brief answer. 1.61. What is the ratio of the ODA received (in %) in Dominica in 2001 to that in 2003?
Your answer should be very brief. 1.79. What is the ratio of the ODA received (in %) of Lebanon in 2001 to that in 2003?
Offer a terse response. 0.35. What is the ratio of the ODA received (in %) in Tunisia in 2001 to that in 2003?
Your answer should be compact. 1.52. What is the ratio of the ODA received (in %) in Comoros in 2001 to that in 2004?
Make the answer very short. 1.74. What is the ratio of the ODA received (in %) of Dominica in 2001 to that in 2004?
Your answer should be very brief. 0.72. What is the ratio of the ODA received (in %) of Lebanon in 2001 to that in 2004?
Provide a short and direct response. 0.86. What is the ratio of the ODA received (in %) of Tunisia in 2001 to that in 2004?
Offer a terse response. 1.47. What is the ratio of the ODA received (in %) in Comoros in 2002 to that in 2003?
Offer a very short reply. 1.44. What is the ratio of the ODA received (in %) in Dominica in 2002 to that in 2003?
Offer a terse response. 2.76. What is the ratio of the ODA received (in %) of Lebanon in 2002 to that in 2003?
Your response must be concise. 0.35. What is the ratio of the ODA received (in %) in Tunisia in 2002 to that in 2003?
Provide a short and direct response. 0.88. What is the ratio of the ODA received (in %) in Comoros in 2002 to that in 2004?
Offer a terse response. 1.56. What is the ratio of the ODA received (in %) in Dominica in 2002 to that in 2004?
Make the answer very short. 1.11. What is the ratio of the ODA received (in %) in Lebanon in 2002 to that in 2004?
Your answer should be very brief. 0.84. What is the ratio of the ODA received (in %) of Tunisia in 2002 to that in 2004?
Offer a very short reply. 0.85. What is the ratio of the ODA received (in %) of Comoros in 2003 to that in 2004?
Offer a very short reply. 1.08. What is the ratio of the ODA received (in %) of Dominica in 2003 to that in 2004?
Offer a terse response. 0.4. What is the ratio of the ODA received (in %) of Lebanon in 2003 to that in 2004?
Ensure brevity in your answer.  2.43. What is the ratio of the ODA received (in %) in Tunisia in 2003 to that in 2004?
Your answer should be compact. 0.96. What is the difference between the highest and the second highest ODA received (in %) of Comoros?
Offer a very short reply. 6.16. What is the difference between the highest and the second highest ODA received (in %) in Dominica?
Ensure brevity in your answer.  0.93. What is the difference between the highest and the second highest ODA received (in %) of Lebanon?
Your answer should be compact. 1.25. What is the difference between the highest and the second highest ODA received (in %) of Tunisia?
Your answer should be compact. 0.55. What is the difference between the highest and the lowest ODA received (in %) in Comoros?
Make the answer very short. 11.45. What is the difference between the highest and the lowest ODA received (in %) of Dominica?
Keep it short and to the point. 6.1. What is the difference between the highest and the lowest ODA received (in %) of Lebanon?
Offer a terse response. 2.11. What is the difference between the highest and the lowest ODA received (in %) in Tunisia?
Your response must be concise. 1.01. 